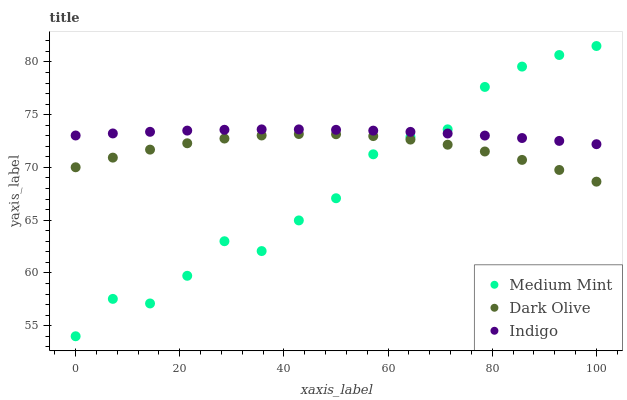Does Medium Mint have the minimum area under the curve?
Answer yes or no. Yes. Does Indigo have the maximum area under the curve?
Answer yes or no. Yes. Does Dark Olive have the minimum area under the curve?
Answer yes or no. No. Does Dark Olive have the maximum area under the curve?
Answer yes or no. No. Is Indigo the smoothest?
Answer yes or no. Yes. Is Medium Mint the roughest?
Answer yes or no. Yes. Is Dark Olive the smoothest?
Answer yes or no. No. Is Dark Olive the roughest?
Answer yes or no. No. Does Medium Mint have the lowest value?
Answer yes or no. Yes. Does Dark Olive have the lowest value?
Answer yes or no. No. Does Medium Mint have the highest value?
Answer yes or no. Yes. Does Indigo have the highest value?
Answer yes or no. No. Is Dark Olive less than Indigo?
Answer yes or no. Yes. Is Indigo greater than Dark Olive?
Answer yes or no. Yes. Does Medium Mint intersect Indigo?
Answer yes or no. Yes. Is Medium Mint less than Indigo?
Answer yes or no. No. Is Medium Mint greater than Indigo?
Answer yes or no. No. Does Dark Olive intersect Indigo?
Answer yes or no. No. 